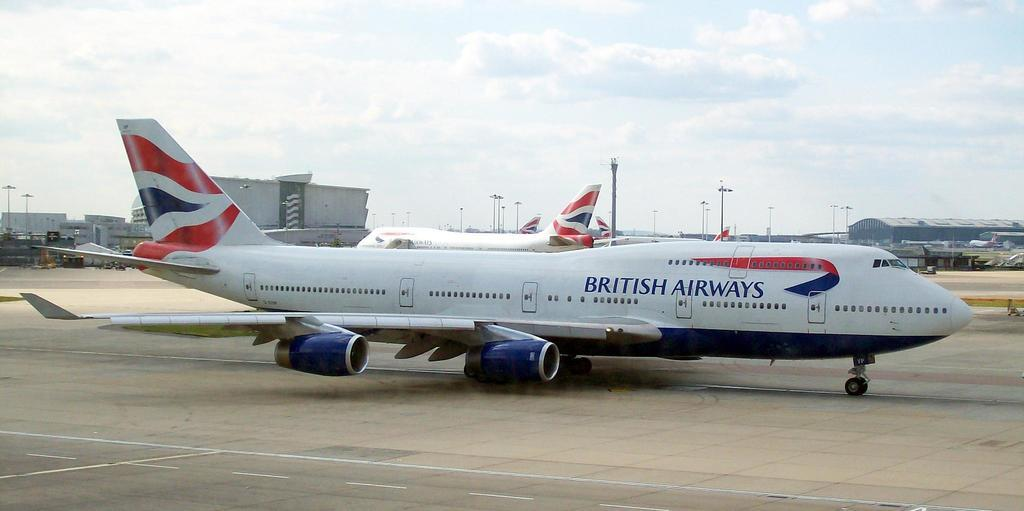<image>
Relay a brief, clear account of the picture shown. A British Airways jet is sitting on the tarmac at an airport. 